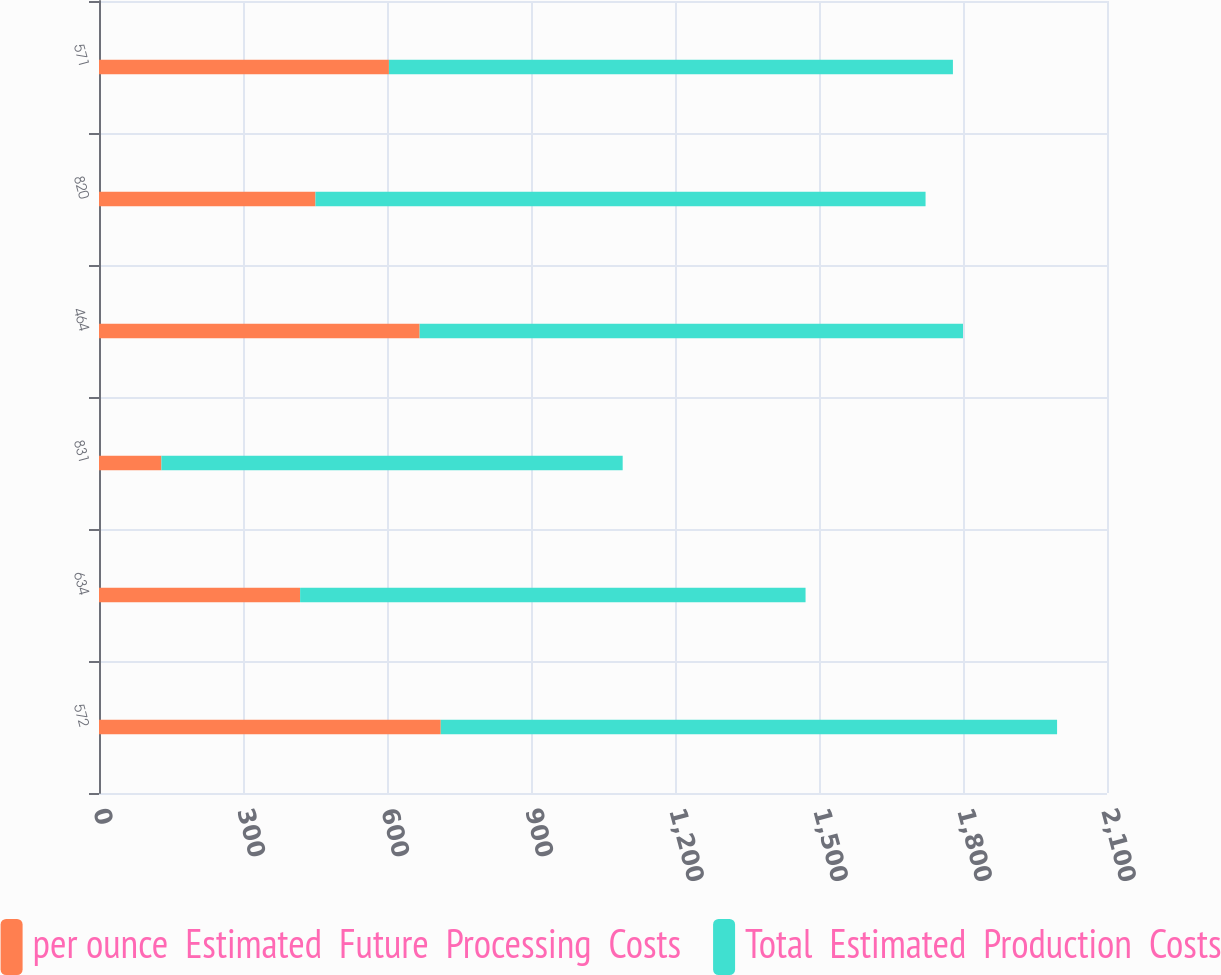<chart> <loc_0><loc_0><loc_500><loc_500><stacked_bar_chart><ecel><fcel>572<fcel>634<fcel>831<fcel>464<fcel>820<fcel>571<nl><fcel>per ounce  Estimated  Future  Processing  Costs<fcel>712<fcel>419<fcel>130<fcel>668<fcel>451<fcel>604<nl><fcel>Total  Estimated  Production  Costs<fcel>1284<fcel>1053<fcel>961<fcel>1132<fcel>1271<fcel>1175<nl></chart> 